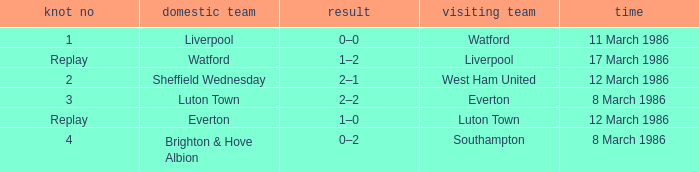Who was the host team in the match against luton town? Everton. 